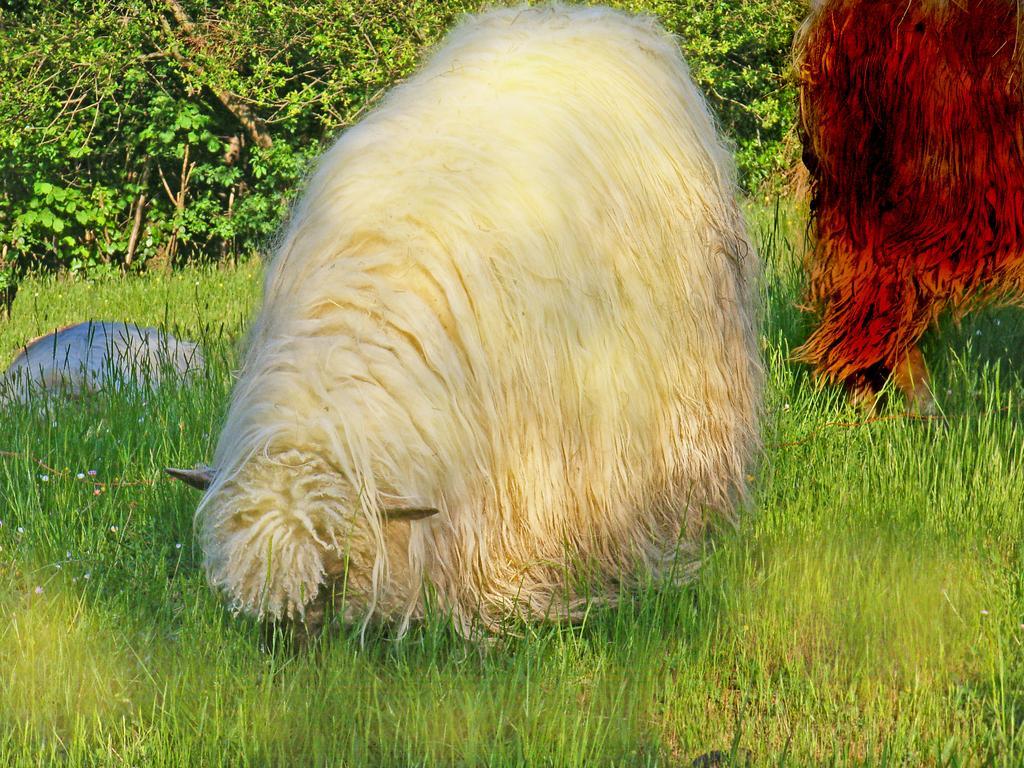Describe this image in one or two sentences. In this image there are a few animals on the surface of the grass. In the background there are trees. 